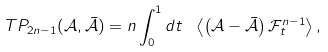Convert formula to latex. <formula><loc_0><loc_0><loc_500><loc_500>T P _ { 2 n - 1 } ( \mathcal { A } , \bar { \mathcal { A } } ) = n \int _ { 0 } ^ { 1 } d t \ \left \langle \left ( \mathcal { A } - \bar { \mathcal { A } } \right ) \mathcal { F } _ { t } ^ { n - 1 } \right \rangle ,</formula> 